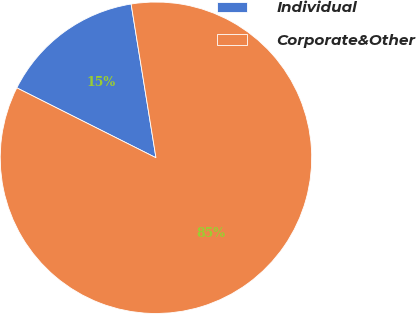Convert chart. <chart><loc_0><loc_0><loc_500><loc_500><pie_chart><fcel>Individual<fcel>Corporate&Other<nl><fcel>15.04%<fcel>84.96%<nl></chart> 